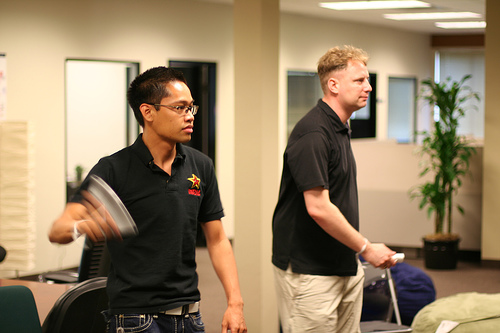Is the Asian man holding the Wii controller on the left side? Yes, the Asian man, who is wearing glasses and looks intently at the screen, holds the Wii controller on his left side. 